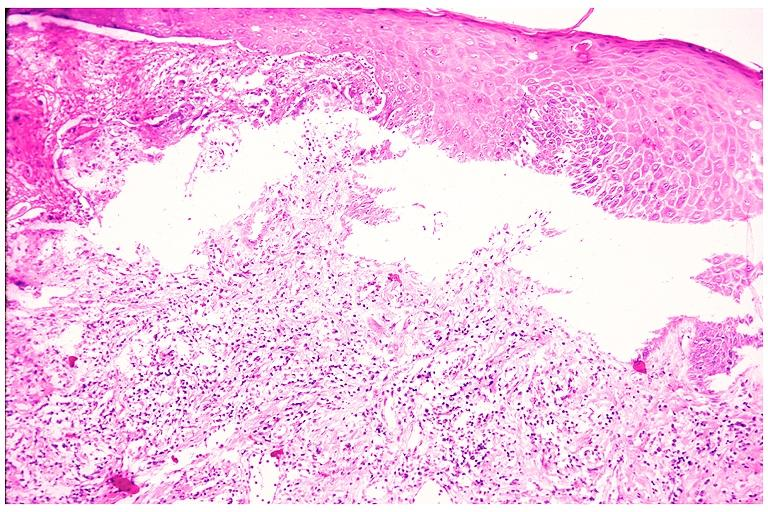s oral present?
Answer the question using a single word or phrase. Yes 